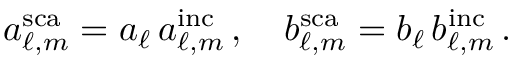Convert formula to latex. <formula><loc_0><loc_0><loc_500><loc_500>a _ { \ell , m } ^ { s c a } = a _ { \ell } \, a _ { \ell , m } ^ { i n c } \, , \quad b _ { \ell , m } ^ { s c a } = b _ { \ell } \, b _ { \ell , m } ^ { i n c } \, .</formula> 